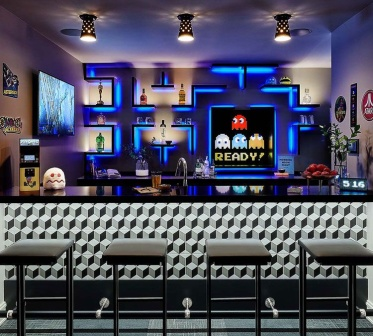Imagine the bar has a live DJ tonight. Describe how the scene changes. The atmosphere in the bar comes alive as the DJ starts spinning electrifying retro beats. The neon lights sync with the music, flashing rhythmically and amplifying the vibrant vibe. Patrons fill the stools and stand around the bar, chatting animatedly while sipping on colorful cocktails. The large screen now alternates between the 'PAC-MAN READY!' message and funky visualizations, pulsating with the sound. The sound system immerses the entire room, making it impossible to sit still as the crowd dances and revels in the nostalgic yet contemporary ambiance.  What conversations might you overhear at this bar when it’s busy? You might overhear groups of friends reminiscing about their childhood days spent playing Pac-Man, couples planning their next retro-themed party, and patrons enthusiastically discussing their high scores on the arcade cabinet. Others might be exchanging opinions on the best cocktails served at the bar or simply getting to know each other, bonding over their shared love for classic games and the unique ambiance of the place. 